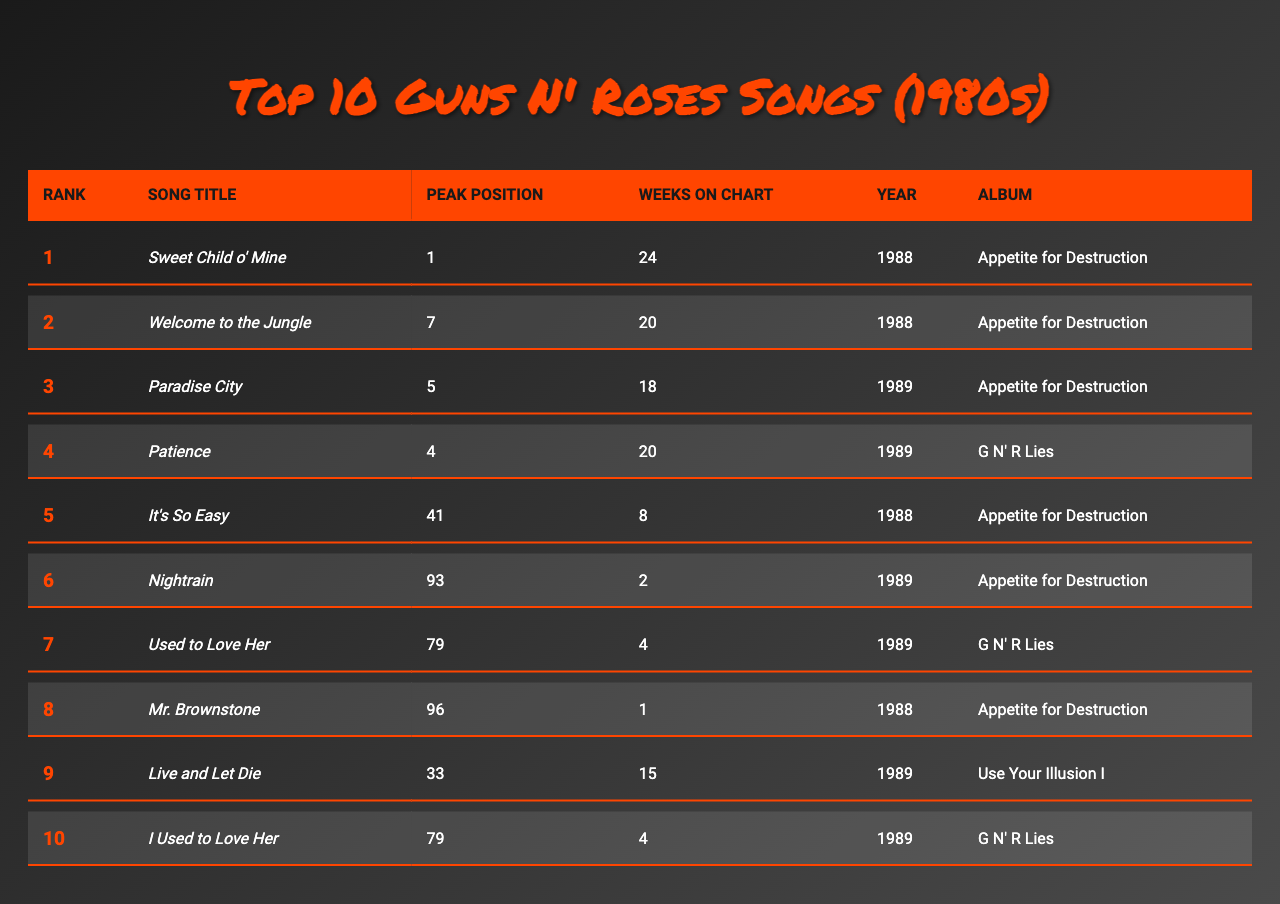What is the highest-ranked Guns N' Roses song of the 1980s? The table shows that "Sweet Child o' Mine" is ranked 1st.
Answer: Sweet Child o' Mine How many weeks did "Paradise City" stay on the chart? According to the table, "Paradise City" stayed on the chart for 18 weeks.
Answer: 18 weeks What year was "Patience" released? The table indicates that "Patience" was released in 1989.
Answer: 1989 Is "It's So Easy" among the top 10 songs by peak position? The peak position of "It's So Easy" is 41, which is not in the top 10. Therefore, it is not among the top 10 songs.
Answer: No Which song had the longest chart presence among the top 10? By examining the "Weeks on Chart" column, "Sweet Child o' Mine" with 24 weeks had the longest presence on the chart, compared to others.
Answer: Sweet Child o' Mine What is the average peak position of the top 5 songs? The peak positions for the top 5 songs are 1, 7, 5, 4, and 41. Adding these gives 1 + 7 + 5 + 4 + 41 = 58. There are 5 songs, so the average is 58 / 5 = 11.6.
Answer: 11.6 How many of the top 10 songs were released in 1988? The songs released in 1988 are "Sweet Child o' Mine", "Welcome to the Jungle", "It's So Easy", and "Mr. Brownstone", totaling to 4 songs.
Answer: 4 Which song had the highest peak position in 1989? The song "Patience" had the highest peak position in 1989 at position 4, compared with others from the same year.
Answer: Patience Was "Live and Let Die" in the top 5 songs by peak position? The peak position of "Live and Let Die" is 33, which is lower than the top 5 peak positions. Therefore, it was not in the top 5.
Answer: No Which album had the most songs in the top 10? "Appetite for Destruction" appears three times in the top 10 songs, making it the album with the most songs.
Answer: Appetite for Destruction 